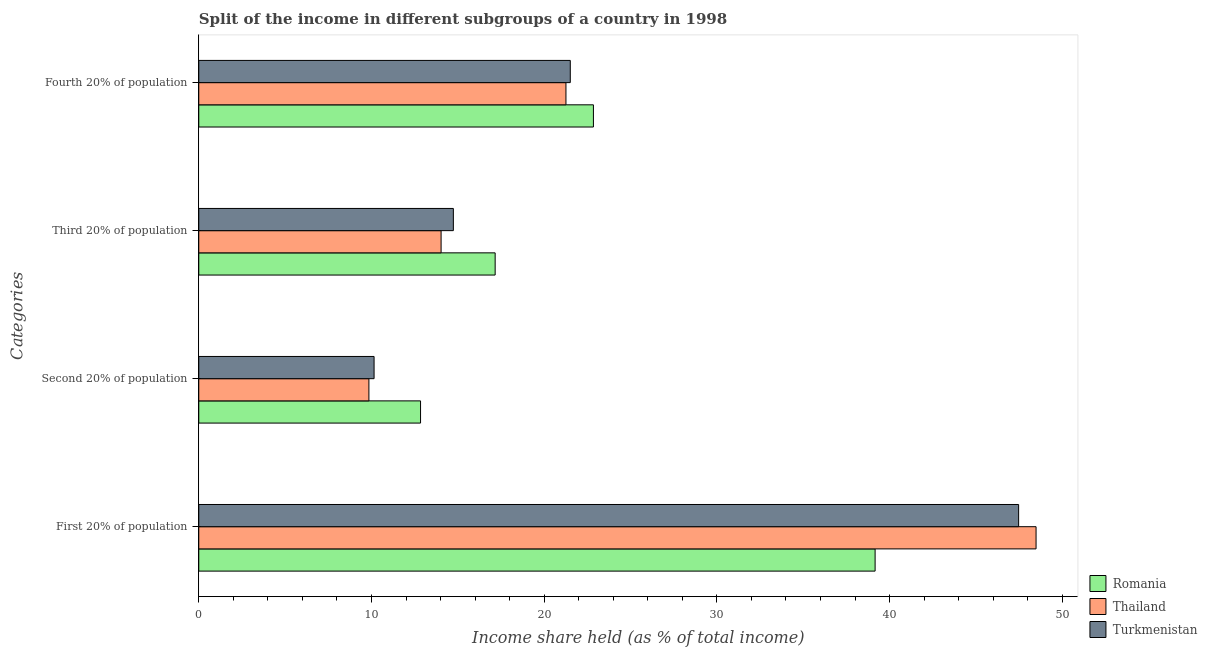How many different coloured bars are there?
Offer a very short reply. 3. Are the number of bars per tick equal to the number of legend labels?
Make the answer very short. Yes. How many bars are there on the 1st tick from the top?
Give a very brief answer. 3. What is the label of the 3rd group of bars from the top?
Offer a terse response. Second 20% of population. What is the share of the income held by second 20% of the population in Romania?
Offer a very short reply. 12.84. Across all countries, what is the maximum share of the income held by third 20% of the population?
Your answer should be very brief. 17.16. Across all countries, what is the minimum share of the income held by first 20% of the population?
Offer a terse response. 39.16. In which country was the share of the income held by third 20% of the population maximum?
Offer a very short reply. Romania. In which country was the share of the income held by third 20% of the population minimum?
Offer a terse response. Thailand. What is the total share of the income held by first 20% of the population in the graph?
Offer a terse response. 135.11. What is the difference between the share of the income held by first 20% of the population in Thailand and that in Turkmenistan?
Make the answer very short. 1.01. What is the difference between the share of the income held by third 20% of the population in Romania and the share of the income held by fourth 20% of the population in Turkmenistan?
Provide a succinct answer. -4.35. What is the average share of the income held by first 20% of the population per country?
Provide a short and direct response. 45.04. What is the difference between the share of the income held by third 20% of the population and share of the income held by fourth 20% of the population in Thailand?
Keep it short and to the point. -7.23. In how many countries, is the share of the income held by first 20% of the population greater than 32 %?
Your response must be concise. 3. What is the ratio of the share of the income held by third 20% of the population in Romania to that in Turkmenistan?
Make the answer very short. 1.16. What is the difference between the highest and the second highest share of the income held by first 20% of the population?
Offer a terse response. 1.01. What is the difference between the highest and the lowest share of the income held by fourth 20% of the population?
Give a very brief answer. 1.59. What does the 3rd bar from the top in First 20% of population represents?
Your answer should be very brief. Romania. What does the 3rd bar from the bottom in Third 20% of population represents?
Ensure brevity in your answer.  Turkmenistan. How many countries are there in the graph?
Offer a terse response. 3. What is the difference between two consecutive major ticks on the X-axis?
Give a very brief answer. 10. Does the graph contain any zero values?
Your answer should be compact. No. Where does the legend appear in the graph?
Your response must be concise. Bottom right. How many legend labels are there?
Offer a very short reply. 3. What is the title of the graph?
Offer a terse response. Split of the income in different subgroups of a country in 1998. Does "South Africa" appear as one of the legend labels in the graph?
Provide a succinct answer. No. What is the label or title of the X-axis?
Your response must be concise. Income share held (as % of total income). What is the label or title of the Y-axis?
Provide a succinct answer. Categories. What is the Income share held (as % of total income) in Romania in First 20% of population?
Ensure brevity in your answer.  39.16. What is the Income share held (as % of total income) in Thailand in First 20% of population?
Offer a very short reply. 48.48. What is the Income share held (as % of total income) of Turkmenistan in First 20% of population?
Keep it short and to the point. 47.47. What is the Income share held (as % of total income) in Romania in Second 20% of population?
Your answer should be compact. 12.84. What is the Income share held (as % of total income) of Thailand in Second 20% of population?
Offer a terse response. 9.85. What is the Income share held (as % of total income) in Turkmenistan in Second 20% of population?
Offer a terse response. 10.15. What is the Income share held (as % of total income) of Romania in Third 20% of population?
Offer a very short reply. 17.16. What is the Income share held (as % of total income) of Thailand in Third 20% of population?
Give a very brief answer. 14.03. What is the Income share held (as % of total income) of Turkmenistan in Third 20% of population?
Keep it short and to the point. 14.74. What is the Income share held (as % of total income) in Romania in Fourth 20% of population?
Give a very brief answer. 22.85. What is the Income share held (as % of total income) of Thailand in Fourth 20% of population?
Provide a succinct answer. 21.26. What is the Income share held (as % of total income) of Turkmenistan in Fourth 20% of population?
Offer a very short reply. 21.51. Across all Categories, what is the maximum Income share held (as % of total income) of Romania?
Ensure brevity in your answer.  39.16. Across all Categories, what is the maximum Income share held (as % of total income) in Thailand?
Make the answer very short. 48.48. Across all Categories, what is the maximum Income share held (as % of total income) of Turkmenistan?
Your response must be concise. 47.47. Across all Categories, what is the minimum Income share held (as % of total income) in Romania?
Offer a very short reply. 12.84. Across all Categories, what is the minimum Income share held (as % of total income) of Thailand?
Make the answer very short. 9.85. Across all Categories, what is the minimum Income share held (as % of total income) in Turkmenistan?
Ensure brevity in your answer.  10.15. What is the total Income share held (as % of total income) of Romania in the graph?
Your answer should be compact. 92.01. What is the total Income share held (as % of total income) in Thailand in the graph?
Ensure brevity in your answer.  93.62. What is the total Income share held (as % of total income) in Turkmenistan in the graph?
Your answer should be very brief. 93.87. What is the difference between the Income share held (as % of total income) of Romania in First 20% of population and that in Second 20% of population?
Your answer should be very brief. 26.32. What is the difference between the Income share held (as % of total income) in Thailand in First 20% of population and that in Second 20% of population?
Provide a short and direct response. 38.63. What is the difference between the Income share held (as % of total income) of Turkmenistan in First 20% of population and that in Second 20% of population?
Your answer should be very brief. 37.32. What is the difference between the Income share held (as % of total income) in Romania in First 20% of population and that in Third 20% of population?
Provide a short and direct response. 22. What is the difference between the Income share held (as % of total income) in Thailand in First 20% of population and that in Third 20% of population?
Offer a very short reply. 34.45. What is the difference between the Income share held (as % of total income) of Turkmenistan in First 20% of population and that in Third 20% of population?
Make the answer very short. 32.73. What is the difference between the Income share held (as % of total income) in Romania in First 20% of population and that in Fourth 20% of population?
Offer a terse response. 16.31. What is the difference between the Income share held (as % of total income) of Thailand in First 20% of population and that in Fourth 20% of population?
Provide a short and direct response. 27.22. What is the difference between the Income share held (as % of total income) of Turkmenistan in First 20% of population and that in Fourth 20% of population?
Give a very brief answer. 25.96. What is the difference between the Income share held (as % of total income) in Romania in Second 20% of population and that in Third 20% of population?
Provide a short and direct response. -4.32. What is the difference between the Income share held (as % of total income) in Thailand in Second 20% of population and that in Third 20% of population?
Offer a terse response. -4.18. What is the difference between the Income share held (as % of total income) of Turkmenistan in Second 20% of population and that in Third 20% of population?
Ensure brevity in your answer.  -4.59. What is the difference between the Income share held (as % of total income) of Romania in Second 20% of population and that in Fourth 20% of population?
Make the answer very short. -10.01. What is the difference between the Income share held (as % of total income) in Thailand in Second 20% of population and that in Fourth 20% of population?
Your answer should be very brief. -11.41. What is the difference between the Income share held (as % of total income) in Turkmenistan in Second 20% of population and that in Fourth 20% of population?
Your answer should be compact. -11.36. What is the difference between the Income share held (as % of total income) in Romania in Third 20% of population and that in Fourth 20% of population?
Provide a succinct answer. -5.69. What is the difference between the Income share held (as % of total income) of Thailand in Third 20% of population and that in Fourth 20% of population?
Offer a very short reply. -7.23. What is the difference between the Income share held (as % of total income) in Turkmenistan in Third 20% of population and that in Fourth 20% of population?
Offer a terse response. -6.77. What is the difference between the Income share held (as % of total income) in Romania in First 20% of population and the Income share held (as % of total income) in Thailand in Second 20% of population?
Ensure brevity in your answer.  29.31. What is the difference between the Income share held (as % of total income) in Romania in First 20% of population and the Income share held (as % of total income) in Turkmenistan in Second 20% of population?
Give a very brief answer. 29.01. What is the difference between the Income share held (as % of total income) in Thailand in First 20% of population and the Income share held (as % of total income) in Turkmenistan in Second 20% of population?
Give a very brief answer. 38.33. What is the difference between the Income share held (as % of total income) of Romania in First 20% of population and the Income share held (as % of total income) of Thailand in Third 20% of population?
Give a very brief answer. 25.13. What is the difference between the Income share held (as % of total income) in Romania in First 20% of population and the Income share held (as % of total income) in Turkmenistan in Third 20% of population?
Offer a very short reply. 24.42. What is the difference between the Income share held (as % of total income) of Thailand in First 20% of population and the Income share held (as % of total income) of Turkmenistan in Third 20% of population?
Provide a succinct answer. 33.74. What is the difference between the Income share held (as % of total income) of Romania in First 20% of population and the Income share held (as % of total income) of Turkmenistan in Fourth 20% of population?
Provide a succinct answer. 17.65. What is the difference between the Income share held (as % of total income) of Thailand in First 20% of population and the Income share held (as % of total income) of Turkmenistan in Fourth 20% of population?
Give a very brief answer. 26.97. What is the difference between the Income share held (as % of total income) in Romania in Second 20% of population and the Income share held (as % of total income) in Thailand in Third 20% of population?
Your response must be concise. -1.19. What is the difference between the Income share held (as % of total income) in Thailand in Second 20% of population and the Income share held (as % of total income) in Turkmenistan in Third 20% of population?
Offer a terse response. -4.89. What is the difference between the Income share held (as % of total income) in Romania in Second 20% of population and the Income share held (as % of total income) in Thailand in Fourth 20% of population?
Offer a terse response. -8.42. What is the difference between the Income share held (as % of total income) in Romania in Second 20% of population and the Income share held (as % of total income) in Turkmenistan in Fourth 20% of population?
Offer a very short reply. -8.67. What is the difference between the Income share held (as % of total income) of Thailand in Second 20% of population and the Income share held (as % of total income) of Turkmenistan in Fourth 20% of population?
Your answer should be compact. -11.66. What is the difference between the Income share held (as % of total income) of Romania in Third 20% of population and the Income share held (as % of total income) of Thailand in Fourth 20% of population?
Offer a terse response. -4.1. What is the difference between the Income share held (as % of total income) in Romania in Third 20% of population and the Income share held (as % of total income) in Turkmenistan in Fourth 20% of population?
Provide a succinct answer. -4.35. What is the difference between the Income share held (as % of total income) of Thailand in Third 20% of population and the Income share held (as % of total income) of Turkmenistan in Fourth 20% of population?
Offer a very short reply. -7.48. What is the average Income share held (as % of total income) in Romania per Categories?
Ensure brevity in your answer.  23. What is the average Income share held (as % of total income) of Thailand per Categories?
Provide a short and direct response. 23.41. What is the average Income share held (as % of total income) in Turkmenistan per Categories?
Keep it short and to the point. 23.47. What is the difference between the Income share held (as % of total income) in Romania and Income share held (as % of total income) in Thailand in First 20% of population?
Provide a succinct answer. -9.32. What is the difference between the Income share held (as % of total income) in Romania and Income share held (as % of total income) in Turkmenistan in First 20% of population?
Give a very brief answer. -8.31. What is the difference between the Income share held (as % of total income) in Romania and Income share held (as % of total income) in Thailand in Second 20% of population?
Your response must be concise. 2.99. What is the difference between the Income share held (as % of total income) of Romania and Income share held (as % of total income) of Turkmenistan in Second 20% of population?
Provide a short and direct response. 2.69. What is the difference between the Income share held (as % of total income) of Romania and Income share held (as % of total income) of Thailand in Third 20% of population?
Provide a short and direct response. 3.13. What is the difference between the Income share held (as % of total income) of Romania and Income share held (as % of total income) of Turkmenistan in Third 20% of population?
Make the answer very short. 2.42. What is the difference between the Income share held (as % of total income) of Thailand and Income share held (as % of total income) of Turkmenistan in Third 20% of population?
Your answer should be compact. -0.71. What is the difference between the Income share held (as % of total income) of Romania and Income share held (as % of total income) of Thailand in Fourth 20% of population?
Keep it short and to the point. 1.59. What is the difference between the Income share held (as % of total income) of Romania and Income share held (as % of total income) of Turkmenistan in Fourth 20% of population?
Keep it short and to the point. 1.34. What is the difference between the Income share held (as % of total income) of Thailand and Income share held (as % of total income) of Turkmenistan in Fourth 20% of population?
Offer a terse response. -0.25. What is the ratio of the Income share held (as % of total income) in Romania in First 20% of population to that in Second 20% of population?
Offer a very short reply. 3.05. What is the ratio of the Income share held (as % of total income) of Thailand in First 20% of population to that in Second 20% of population?
Make the answer very short. 4.92. What is the ratio of the Income share held (as % of total income) in Turkmenistan in First 20% of population to that in Second 20% of population?
Provide a succinct answer. 4.68. What is the ratio of the Income share held (as % of total income) in Romania in First 20% of population to that in Third 20% of population?
Ensure brevity in your answer.  2.28. What is the ratio of the Income share held (as % of total income) in Thailand in First 20% of population to that in Third 20% of population?
Your answer should be very brief. 3.46. What is the ratio of the Income share held (as % of total income) in Turkmenistan in First 20% of population to that in Third 20% of population?
Provide a succinct answer. 3.22. What is the ratio of the Income share held (as % of total income) in Romania in First 20% of population to that in Fourth 20% of population?
Keep it short and to the point. 1.71. What is the ratio of the Income share held (as % of total income) in Thailand in First 20% of population to that in Fourth 20% of population?
Provide a short and direct response. 2.28. What is the ratio of the Income share held (as % of total income) of Turkmenistan in First 20% of population to that in Fourth 20% of population?
Your answer should be compact. 2.21. What is the ratio of the Income share held (as % of total income) in Romania in Second 20% of population to that in Third 20% of population?
Your response must be concise. 0.75. What is the ratio of the Income share held (as % of total income) of Thailand in Second 20% of population to that in Third 20% of population?
Keep it short and to the point. 0.7. What is the ratio of the Income share held (as % of total income) of Turkmenistan in Second 20% of population to that in Third 20% of population?
Provide a short and direct response. 0.69. What is the ratio of the Income share held (as % of total income) in Romania in Second 20% of population to that in Fourth 20% of population?
Give a very brief answer. 0.56. What is the ratio of the Income share held (as % of total income) of Thailand in Second 20% of population to that in Fourth 20% of population?
Give a very brief answer. 0.46. What is the ratio of the Income share held (as % of total income) of Turkmenistan in Second 20% of population to that in Fourth 20% of population?
Offer a terse response. 0.47. What is the ratio of the Income share held (as % of total income) of Romania in Third 20% of population to that in Fourth 20% of population?
Give a very brief answer. 0.75. What is the ratio of the Income share held (as % of total income) in Thailand in Third 20% of population to that in Fourth 20% of population?
Provide a short and direct response. 0.66. What is the ratio of the Income share held (as % of total income) in Turkmenistan in Third 20% of population to that in Fourth 20% of population?
Make the answer very short. 0.69. What is the difference between the highest and the second highest Income share held (as % of total income) of Romania?
Offer a terse response. 16.31. What is the difference between the highest and the second highest Income share held (as % of total income) in Thailand?
Keep it short and to the point. 27.22. What is the difference between the highest and the second highest Income share held (as % of total income) of Turkmenistan?
Your answer should be very brief. 25.96. What is the difference between the highest and the lowest Income share held (as % of total income) of Romania?
Your response must be concise. 26.32. What is the difference between the highest and the lowest Income share held (as % of total income) in Thailand?
Give a very brief answer. 38.63. What is the difference between the highest and the lowest Income share held (as % of total income) in Turkmenistan?
Give a very brief answer. 37.32. 